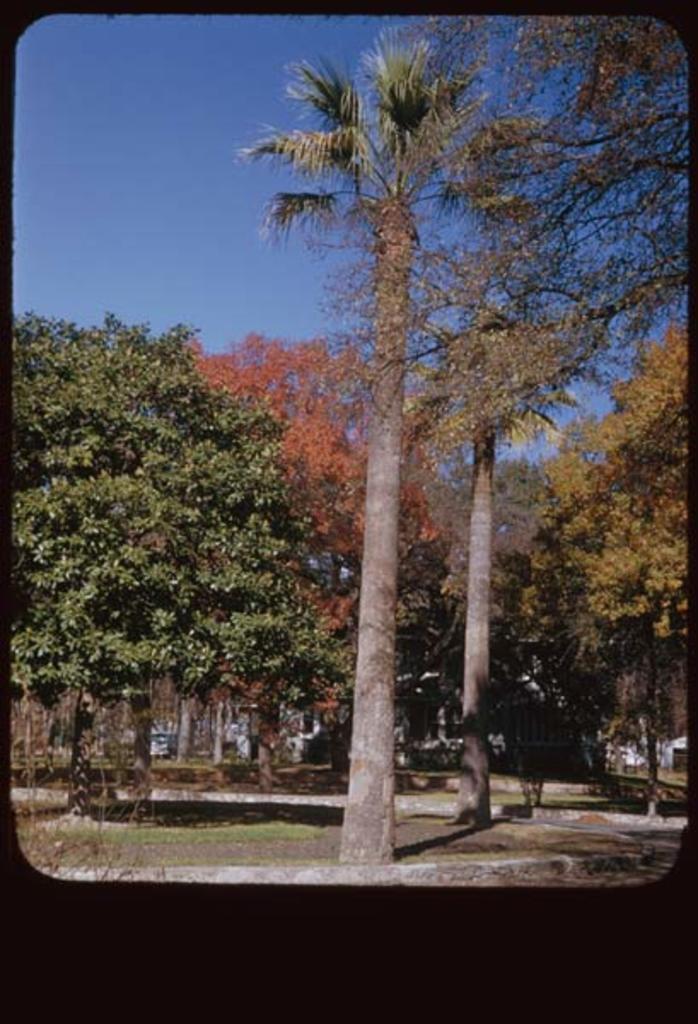Describe this image in one or two sentences. The picture might be taken in a park. In this picture we can see lot of trees, grass and other objects. At the top there is sky. The picture has a black border. 